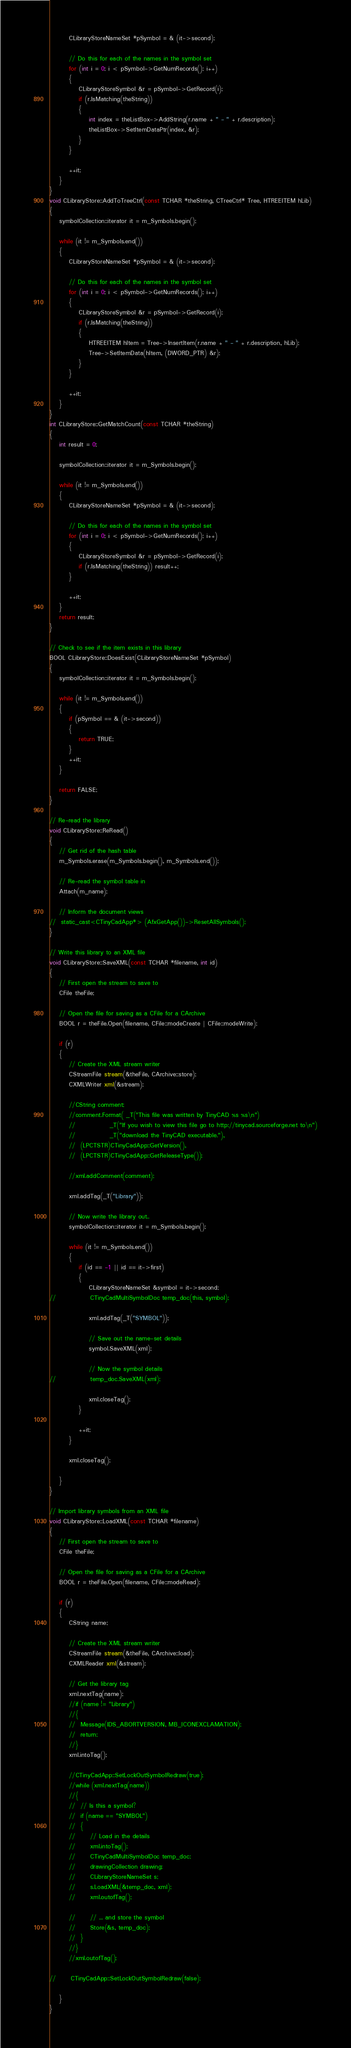<code> <loc_0><loc_0><loc_500><loc_500><_C++_>		CLibraryStoreNameSet *pSymbol = & (it->second);

		// Do this for each of the names in the symbol set
		for (int i = 0; i < pSymbol->GetNumRecords(); i++)
		{
			CLibraryStoreSymbol &r = pSymbol->GetRecord(i);
			if (r.IsMatching(theString))
			{
				int index = theListBox->AddString(r.name + " - " + r.description);
				theListBox->SetItemDataPtr(index, &r);
			}
		}

		++it;
	}
}
void CLibraryStore::AddToTreeCtrl(const TCHAR *theString, CTreeCtrl* Tree, HTREEITEM hLib)
{
	symbolCollection::iterator it = m_Symbols.begin();

	while (it != m_Symbols.end())
	{
		CLibraryStoreNameSet *pSymbol = & (it->second);

		// Do this for each of the names in the symbol set
		for (int i = 0; i < pSymbol->GetNumRecords(); i++)
		{
			CLibraryStoreSymbol &r = pSymbol->GetRecord(i);
			if (r.IsMatching(theString))
			{
				HTREEITEM hItem = Tree->InsertItem(r.name + " - " + r.description, hLib);
				Tree->SetItemData(hItem, (DWORD_PTR) &r);
			}
		}

		++it;
	}
}
int CLibraryStore::GetMatchCount(const TCHAR *theString)
{
	int result = 0;

	symbolCollection::iterator it = m_Symbols.begin();

	while (it != m_Symbols.end())
	{
		CLibraryStoreNameSet *pSymbol = & (it->second);

		// Do this for each of the names in the symbol set
		for (int i = 0; i < pSymbol->GetNumRecords(); i++)
		{
			CLibraryStoreSymbol &r = pSymbol->GetRecord(i);
			if (r.IsMatching(theString)) result++;
		}

		++it;
	}
	return result;
}

// Check to see if the item exists in this library
BOOL CLibraryStore::DoesExist(CLibraryStoreNameSet *pSymbol)
{
	symbolCollection::iterator it = m_Symbols.begin();

	while (it != m_Symbols.end())
	{
		if (pSymbol == & (it->second))
		{
			return TRUE;
		}
		++it;
	}

	return FALSE;
}

// Re-read the library
void CLibraryStore::ReRead()
{
	// Get rid of the hash table
	m_Symbols.erase(m_Symbols.begin(), m_Symbols.end());

	// Re-read the symbol table in
	Attach(m_name);

	// Inform the document views
//	static_cast<CTinyCadApp*> (AfxGetApp())->ResetAllSymbols();
}

// Write this library to an XML file
void CLibraryStore::SaveXML(const TCHAR *filename, int id)
{
	// First open the stream to save to
	CFile theFile;

	// Open the file for saving as a CFile for a CArchive
	BOOL r = theFile.Open(filename, CFile::modeCreate | CFile::modeWrite);

	if (r)
	{
		// Create the XML stream writer
		CStreamFile stream(&theFile, CArchive::store);
		CXMLWriter xml(&stream);

		//CString comment;
		//comment.Format( _T("This file was written by TinyCAD %s %s\n")
		//				_T("If you wish to view this file go to http://tinycad.sourceforge.net to\n")
		//				_T("download the TinyCAD executable."),
		//	(LPCTSTR)CTinyCadApp::GetVersion(),
		//	(LPCTSTR)CTinyCadApp::GetReleaseType());

		//xml.addComment(comment);

		xml.addTag(_T("Library"));

		// Now write the library out..
		symbolCollection::iterator it = m_Symbols.begin();

		while (it != m_Symbols.end())
		{
			if (id == -1 || id == it->first)
			{
				CLibraryStoreNameSet &symbol = it->second;
//				CTinyCadMultiSymbolDoc temp_doc(this, symbol);

				xml.addTag(_T("SYMBOL"));

				// Save out the name-set details
				symbol.SaveXML(xml);

				// Now the symbol details
//				temp_doc.SaveXML(xml);

				xml.closeTag();
			}

			++it;
		}

		xml.closeTag();

	}
}

// Import library symbols from an XML file
void CLibraryStore::LoadXML(const TCHAR *filename)
{
	// First open the stream to save to
	CFile theFile;

	// Open the file for saving as a CFile for a CArchive
	BOOL r = theFile.Open(filename, CFile::modeRead);

	if (r)
	{
		CString name;

		// Create the XML stream writer
		CStreamFile stream(&theFile, CArchive::load);
		CXMLReader xml(&stream);

		// Get the library tag
		xml.nextTag(name);
		//if (name != "Library")
		//{
		//	Message(IDS_ABORTVERSION, MB_ICONEXCLAMATION);
		//	return;
		//}
		xml.intoTag();

		//CTinyCadApp::SetLockOutSymbolRedraw(true);
		//while (xml.nextTag(name))
		//{
		//	// Is this a symbol?
		//	if (name == "SYMBOL")
		//	{
		//		// Load in the details
		//		xml.intoTag();
		//		CTinyCadMultiSymbolDoc temp_doc;
		//		drawingCollection drawing;
		//		CLibraryStoreNameSet s;
		//		s.LoadXML(&temp_doc, xml);
		//		xml.outofTag();

		//		// ... and store the symbol
		//		Store(&s, temp_doc);
		//	}
		//}
		//xml.outofTag();

//		CTinyCadApp::SetLockOutSymbolRedraw(false);

	}
}
</code> 